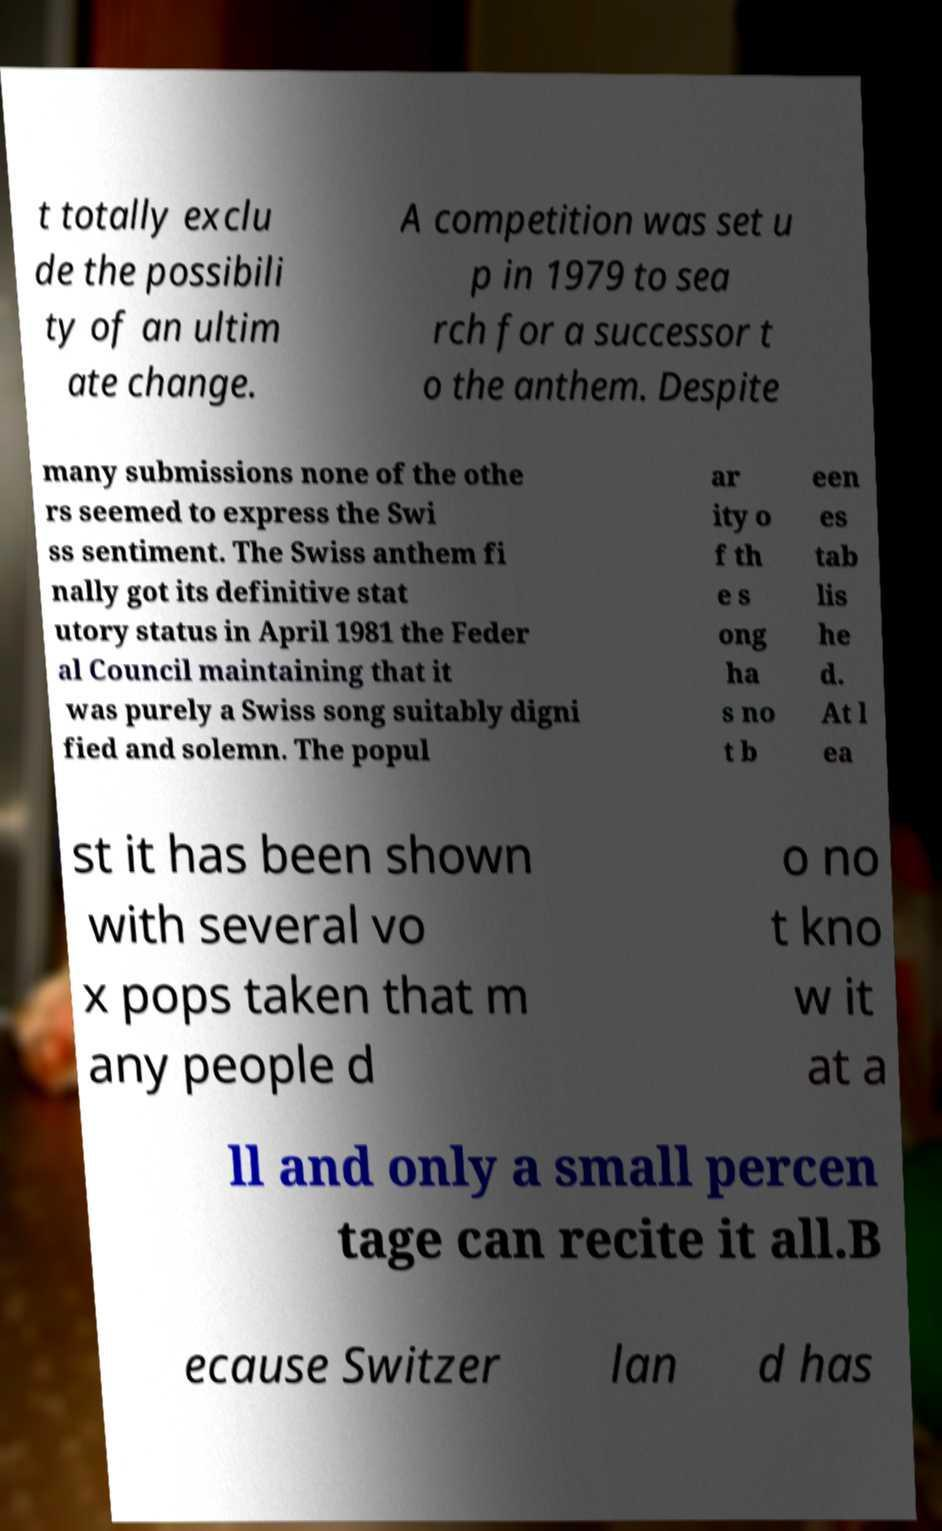Please identify and transcribe the text found in this image. t totally exclu de the possibili ty of an ultim ate change. A competition was set u p in 1979 to sea rch for a successor t o the anthem. Despite many submissions none of the othe rs seemed to express the Swi ss sentiment. The Swiss anthem fi nally got its definitive stat utory status in April 1981 the Feder al Council maintaining that it was purely a Swiss song suitably digni fied and solemn. The popul ar ity o f th e s ong ha s no t b een es tab lis he d. At l ea st it has been shown with several vo x pops taken that m any people d o no t kno w it at a ll and only a small percen tage can recite it all.B ecause Switzer lan d has 